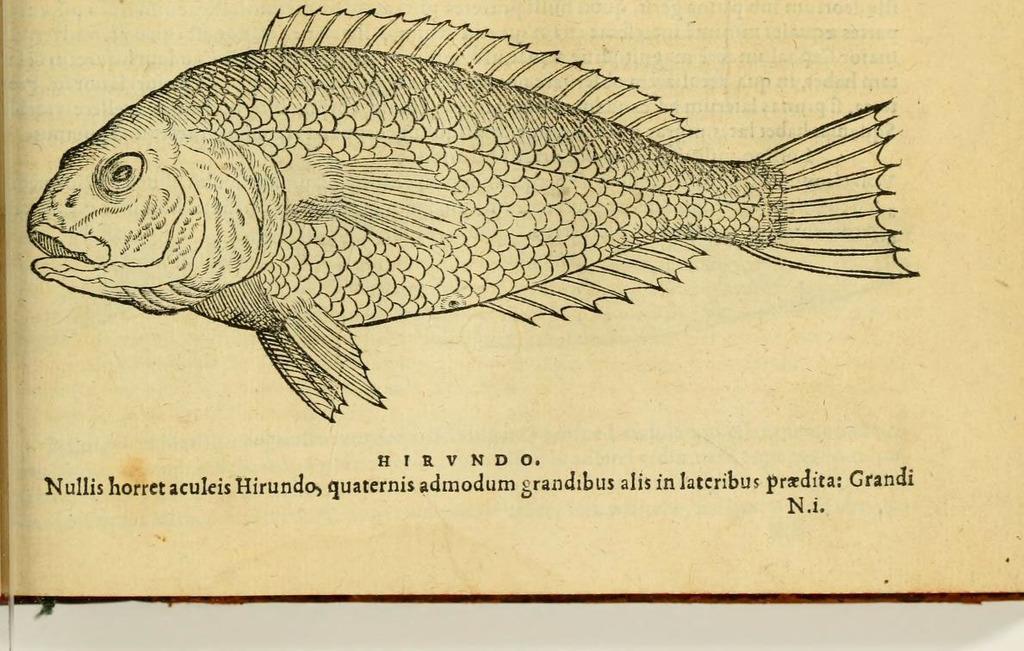Could you give a brief overview of what you see in this image? I can see this is an picture of fish and at the bottom of the image there is a text written describing about the fish. And the background is half white. 